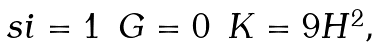Convert formula to latex. <formula><loc_0><loc_0><loc_500><loc_500>\begin{array} { c c c } \ s i = 1 & G = 0 & K = 9 H ^ { 2 } , \end{array}</formula> 